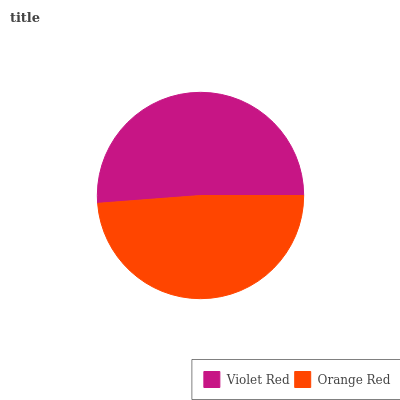Is Orange Red the minimum?
Answer yes or no. Yes. Is Violet Red the maximum?
Answer yes or no. Yes. Is Orange Red the maximum?
Answer yes or no. No. Is Violet Red greater than Orange Red?
Answer yes or no. Yes. Is Orange Red less than Violet Red?
Answer yes or no. Yes. Is Orange Red greater than Violet Red?
Answer yes or no. No. Is Violet Red less than Orange Red?
Answer yes or no. No. Is Violet Red the high median?
Answer yes or no. Yes. Is Orange Red the low median?
Answer yes or no. Yes. Is Orange Red the high median?
Answer yes or no. No. Is Violet Red the low median?
Answer yes or no. No. 